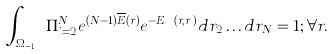Convert formula to latex. <formula><loc_0><loc_0><loc_500><loc_500>\int _ { \Omega _ { N - 1 } } \Pi _ { i = 2 } ^ { N } e ^ { ( N - 1 ) { \overline { E } } ( { r } ) } e ^ { - E _ { e e } ( { r } , { r } _ { i } ) } d { r } _ { 2 } \dots d { r } _ { N } = 1 ; \forall { r } .</formula> 